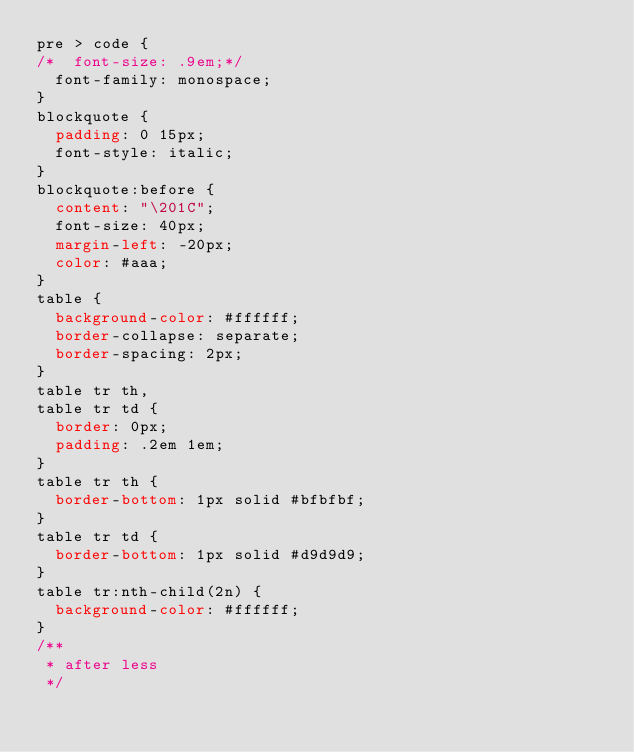<code> <loc_0><loc_0><loc_500><loc_500><_CSS_>pre > code {
/*  font-size: .9em;*/
  font-family: monospace;
}
blockquote {
  padding: 0 15px;
  font-style: italic;
}
blockquote:before {
  content: "\201C";
  font-size: 40px;
  margin-left: -20px;
  color: #aaa;
}
table {
  background-color: #ffffff;
  border-collapse: separate;
  border-spacing: 2px;
}
table tr th,
table tr td {
  border: 0px;
  padding: .2em 1em;
}
table tr th {
  border-bottom: 1px solid #bfbfbf;
}
table tr td {
  border-bottom: 1px solid #d9d9d9;
}
table tr:nth-child(2n) {
  background-color: #ffffff;
}
/**
 * after less
 */
</code> 